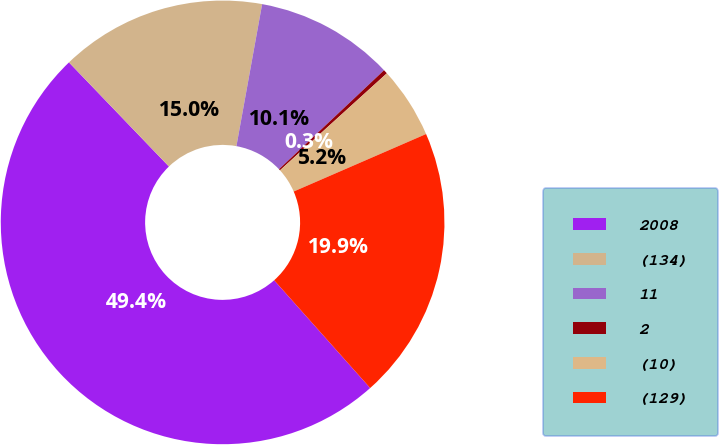<chart> <loc_0><loc_0><loc_500><loc_500><pie_chart><fcel>2008<fcel>(134)<fcel>11<fcel>2<fcel>(10)<fcel>(129)<nl><fcel>49.41%<fcel>15.03%<fcel>10.12%<fcel>0.3%<fcel>5.21%<fcel>19.94%<nl></chart> 